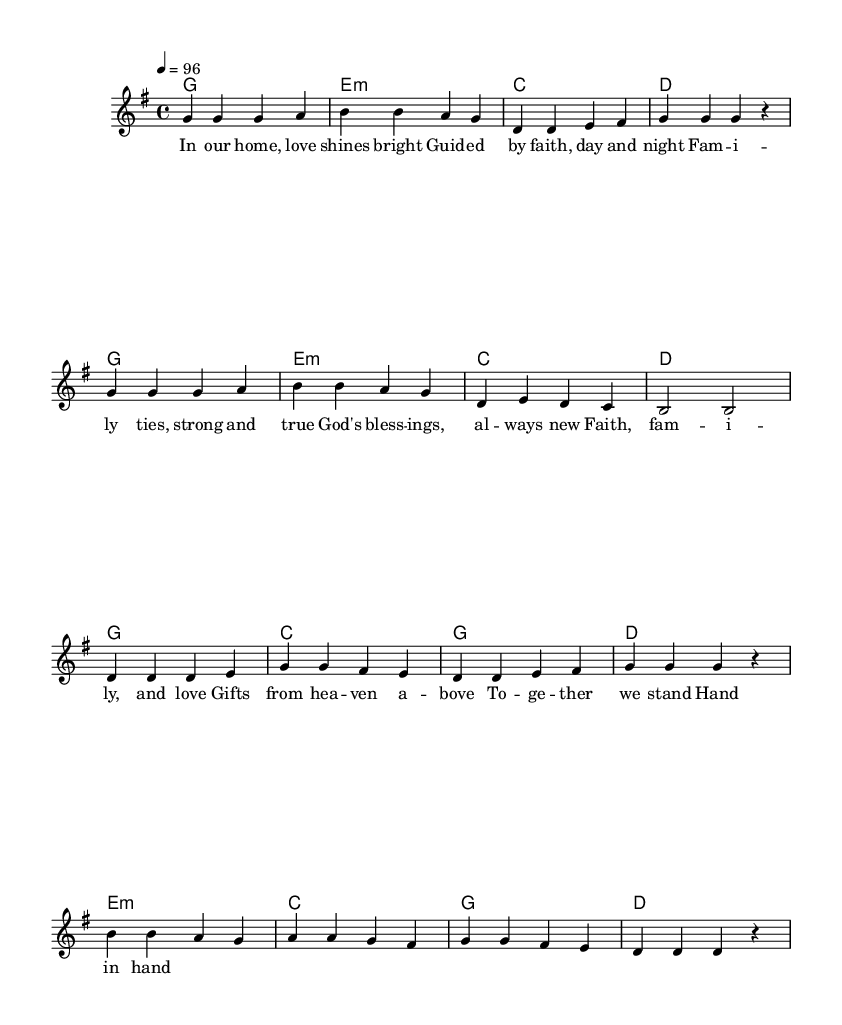What is the key signature of this music? The key signature is G major, which has one sharp. This can be identified by looking at the key signature area at the beginning of the sheet music where you would see the sharp symbol for F#.
Answer: G major What is the time signature of this music? The time signature is 4/4, which means there are four beats in each measure. This is indicated by the "4/4" written at the beginning of the score.
Answer: 4/4 What is the tempo marking for this piece? The tempo is marked as "4 = 96", indicating a tempo of 96 beats per minute. This can be found in the tempo indication near the beginning of the score.
Answer: 96 How many measures are in the verse section? The verse section consists of 8 measures. Counting the measures indicated in the music, there are four for each repeat of the phrase.
Answer: 8 What chords are played in the chorus? The chords in the chorus include G, C, D, and E minor. These can be identified by looking at the chord symbols that appear above the melody line during the chorus part of the score.
Answer: G, C, D, E minor What themes are highlighted in the lyrics of the verse? The lyrics of the verse focus on love, faith, and family ties. This interpretation stems from the text provided, reflecting positive and strong family values and divine blessings.
Answer: Love, faith, family How are the rhythms structured in the chorus? The rhythm in the chorus alternates between half notes and quarter notes, typically creating an uplifting and steady feel fitting for rhythm and blues. This can be discerned from the arrangement of note values in the melody section.
Answer: Alternating half notes and quarter notes 